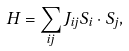<formula> <loc_0><loc_0><loc_500><loc_500>H = \sum _ { i j } J _ { i j } \vec { S } _ { i } \cdot \vec { S } _ { j } ,</formula> 